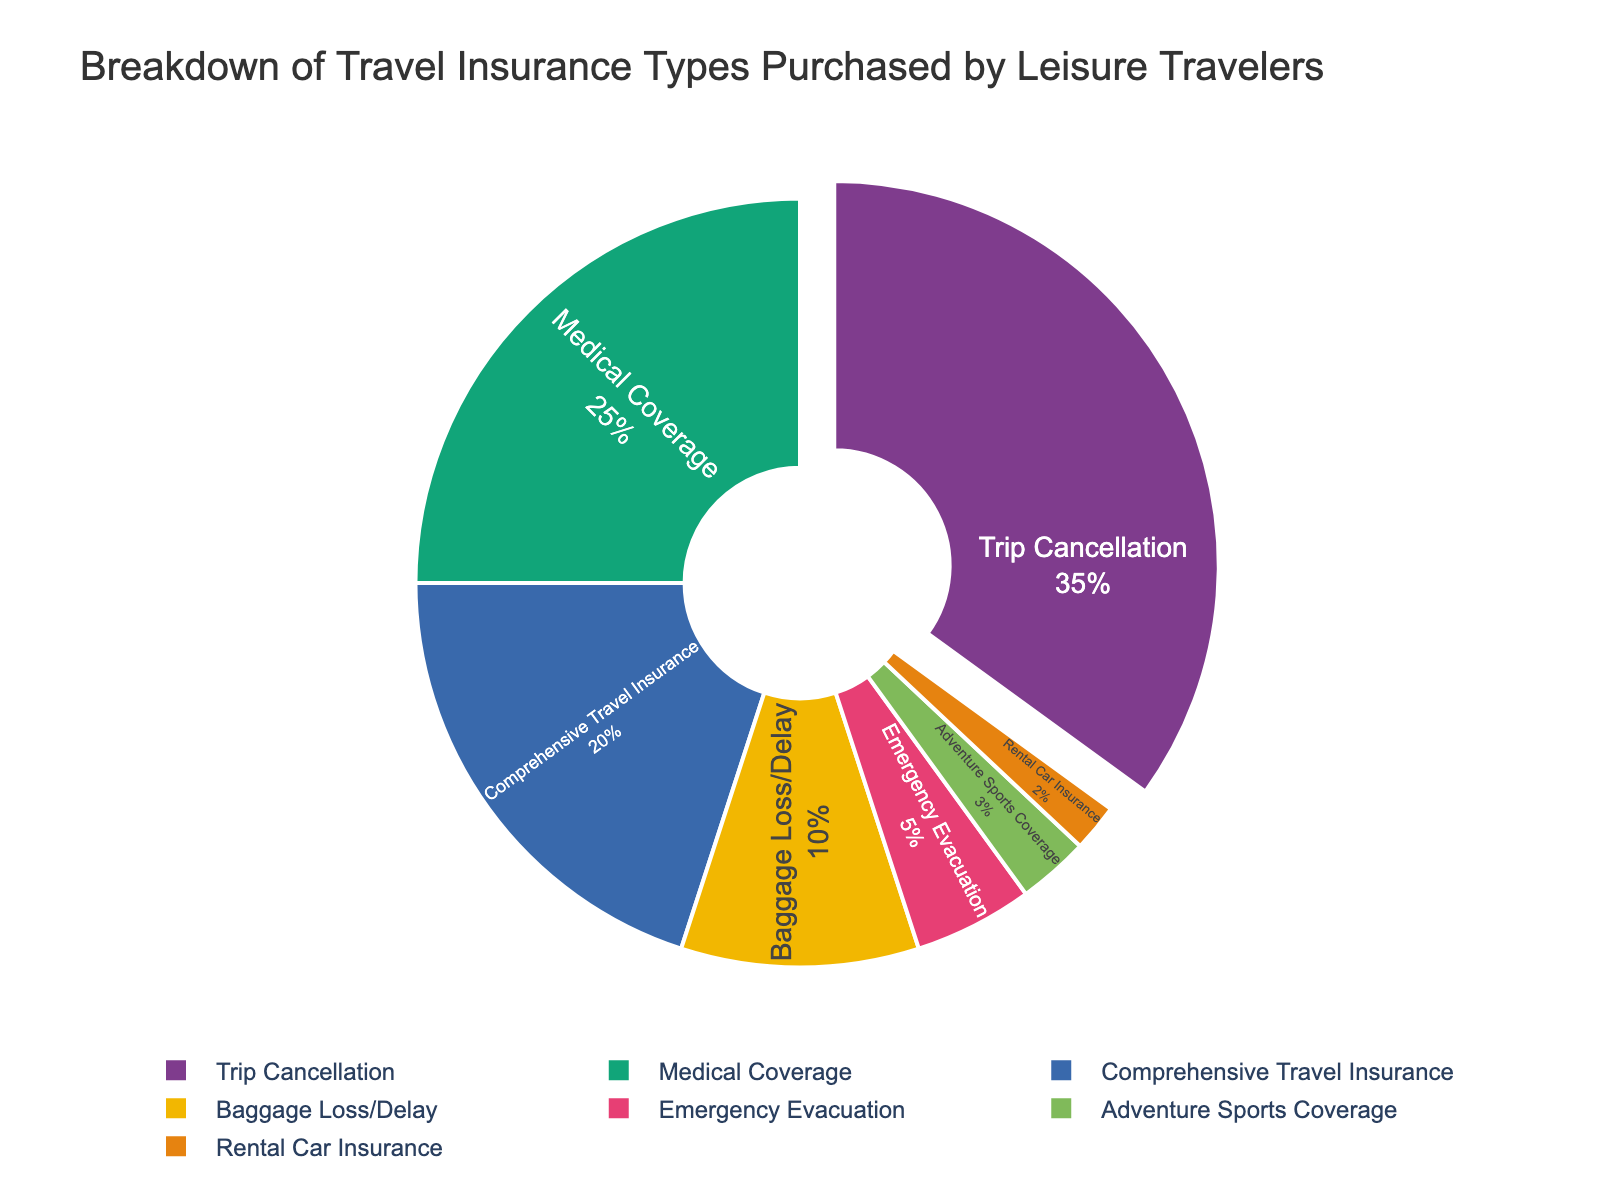What percentage of leisure travelers purchased trip cancellation insurance? Refer to the pie chart and locate the segment labeled "Trip Cancellation" to identify its percentage.
Answer: 35% Which type of insurance has the smallest share among leisure travelers? Examine the pie chart and identify the segment with the smallest percentage.
Answer: Rental Car Insurance How much more popular is medical coverage than adventure sports coverage? Refer to the chart, find the percentages for both "Medical Coverage" and "Adventure Sports Coverage," and subtract the latter from the former: 25% - 3% = 22%
Answer: 22% Are baggage loss/delay and emergency evacuation collectively more popular than comprehensive travel insurance? Sum the percentages for "Baggage Loss/Delay" and "Emergency Evacuation": 10% + 5% = 15%. Compare this with the percentage for "Comprehensive Travel Insurance" (20%).
Answer: No What is the combined percentage of leisure travelers who purchased emergency evacuation and rental car insurance? Add the percentages of "Emergency Evacuation" (5%) and "Rental Car Insurance" (2%): 5% + 2% = 7%
Answer: 7% Which type of insurance has the second-highest percentage and what is it? From the pie chart, identify the segment with the highest percentage (Trip Cancellation at 35%) and then look for the segment with the next highest percentage.
Answer: Medical Coverage, 25% Is the percentage of travelers opting for comprehensive travel insurance greater than those choosing baggage loss/delay and emergency evacuation combined? Sum the percentages for "Baggage Loss/Delay" and "Emergency Evacuation": 10% + 5% = 15%. Compare this with "Comprehensive Travel Insurance" at 20%.
Answer: Yes 